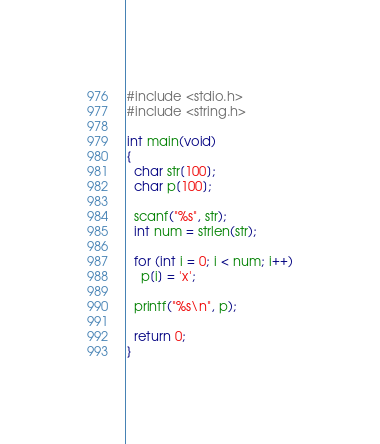<code> <loc_0><loc_0><loc_500><loc_500><_C_>#include <stdio.h>
#include <string.h>

int main(void)
{
  char str[100];
  char p[100];

  scanf("%s", str);
  int num = strlen(str);

  for (int i = 0; i < num; i++)
    p[i] = 'x';

  printf("%s\n", p);

  return 0;
}
</code> 